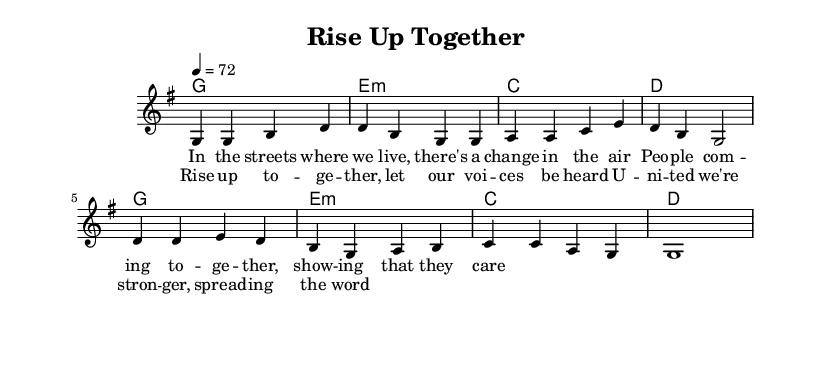What is the key signature of this music? The key signature in the provided sheet music is G major, indicated by one sharp (F#) at the beginning.
Answer: G major What is the time signature of this music? The time signature is represented at the beginning of the sheet music and is set to 4/4, meaning there are four beats per measure.
Answer: 4/4 What is the tempo marking for this piece? The tempo marking provided is 4 = 72, which indicates that there are 72 beats per minute.
Answer: 72 How many measures are in the verse section? The verse section contains four measures as indicated by the bars separated in the melody section.
Answer: Four What is the main theme of the chorus lyrics? The chorus lyrics emphasize unity and collective action, encouraging people to rise together and make their voices heard in the community.
Answer: Unity and collective action Which harmonic chord is used in the first measure of the verse? The first measure of the verse has a G major chord, shown in the chord progression.
Answer: G major What type of musical form does this song exemplify? The song follows a verse-chorus structure, where verses are followed by the chorus, which is characteristic of many soul music pieces focusing on themes of community.
Answer: Verse-chorus 